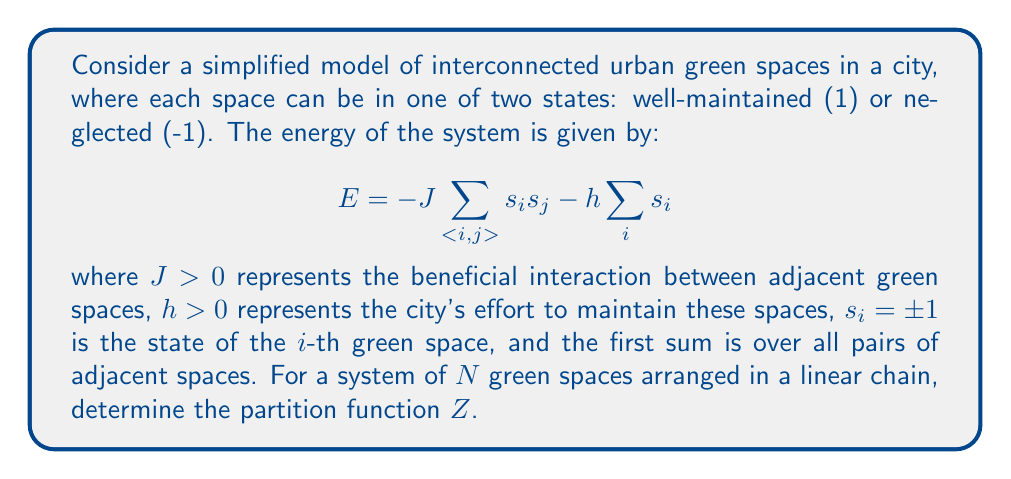Provide a solution to this math problem. To solve this problem, we'll follow these steps:

1) The partition function is defined as:

   $$Z = \sum_{\{s_i\}} e^{-\beta E}$$

   where $\beta = \frac{1}{k_B T}$, $k_B$ is Boltzmann's constant, and $T$ is temperature.

2) Substituting the energy expression:

   $$Z = \sum_{\{s_i\}} \exp\left(\beta J\sum_{<i,j>} s_i s_j + \beta h\sum_i s_i\right)$$

3) For a linear chain, we can rewrite this as:

   $$Z = \sum_{\{s_i\}} \exp\left(\beta J\sum_{i=1}^{N-1} s_i s_{i+1} + \beta h\sum_{i=1}^N s_i\right)$$

4) This form is similar to the one-dimensional Ising model with an external field. We can solve it using the transfer matrix method.

5) Define the transfer matrix $T$:

   $$T = \begin{pmatrix}
   e^{\beta(J+h)} & e^{-\beta J} \\
   e^{-\beta J} & e^{\beta(J-h)}
   \end{pmatrix}$$

6) The partition function can be expressed as:

   $$Z = \text{Tr}(T^N)$$

7) The eigenvalues of $T$ are:

   $$\lambda_{\pm} = e^{\beta J} \cosh(\beta h) \pm \sqrt{e^{2\beta J} \sinh^2(\beta h) + e^{-2\beta J}}$$

8) Therefore, the partition function is:

   $$Z = \lambda_+^N + \lambda_-^N$$

This is the exact solution for the partition function of this system.
Answer: $$Z = \left(e^{\beta J} \cosh(\beta h) + \sqrt{e^{2\beta J} \sinh^2(\beta h) + e^{-2\beta J}}\right)^N + \left(e^{\beta J} \cosh(\beta h) - \sqrt{e^{2\beta J} \sinh^2(\beta h) + e^{-2\beta J}}\right)^N$$ 